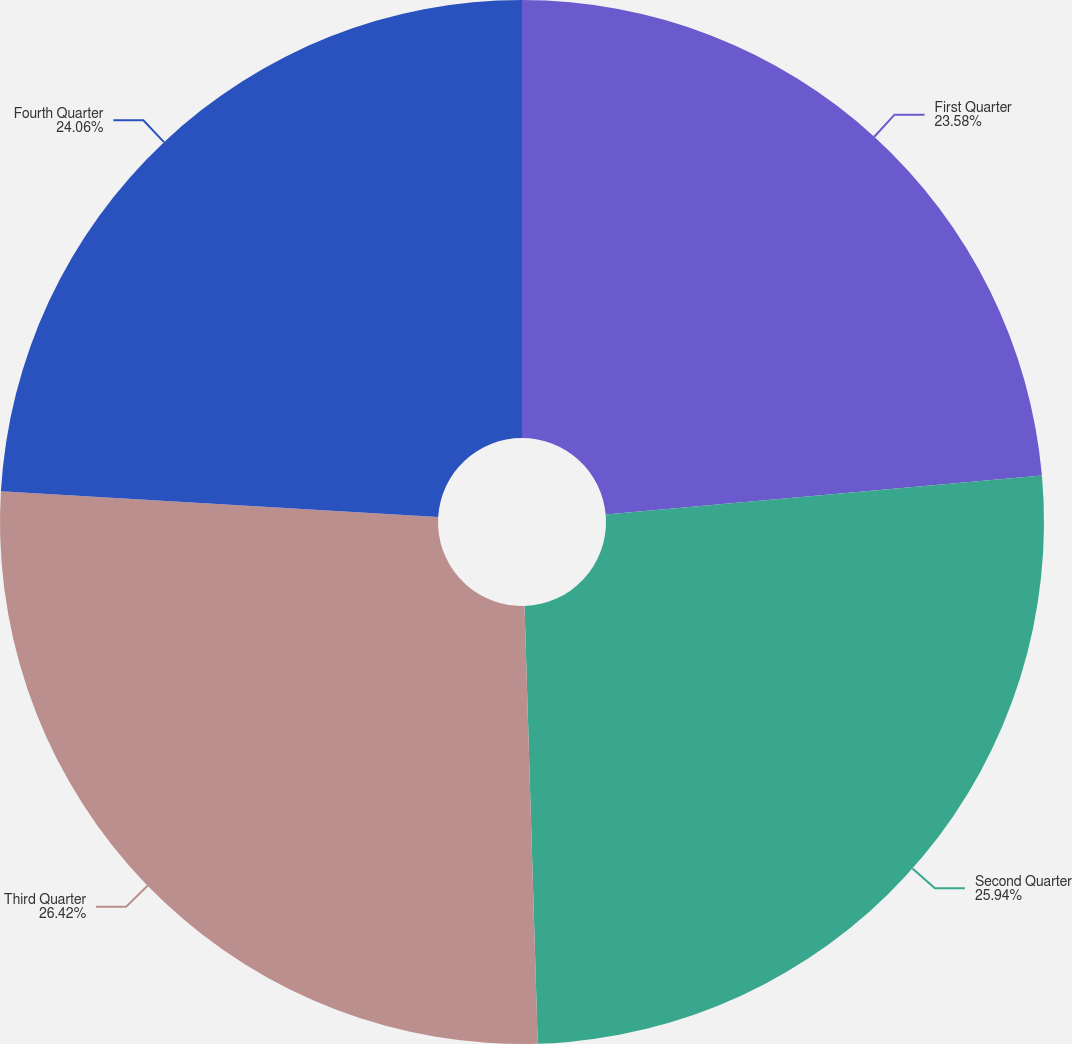Convert chart. <chart><loc_0><loc_0><loc_500><loc_500><pie_chart><fcel>First Quarter<fcel>Second Quarter<fcel>Third Quarter<fcel>Fourth Quarter<nl><fcel>23.58%<fcel>25.94%<fcel>26.42%<fcel>24.06%<nl></chart> 